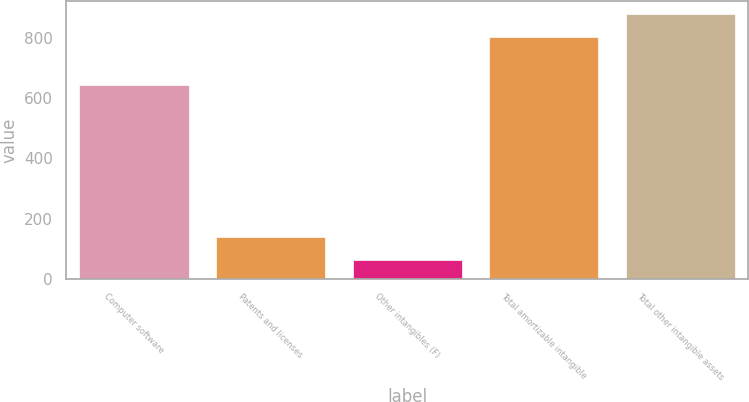<chart> <loc_0><loc_0><loc_500><loc_500><bar_chart><fcel>Computer software<fcel>Patents and licenses<fcel>Other intangibles (F)<fcel>Total amortizable intangible<fcel>Total other intangible assets<nl><fcel>643<fcel>138.1<fcel>64<fcel>805<fcel>879.1<nl></chart> 